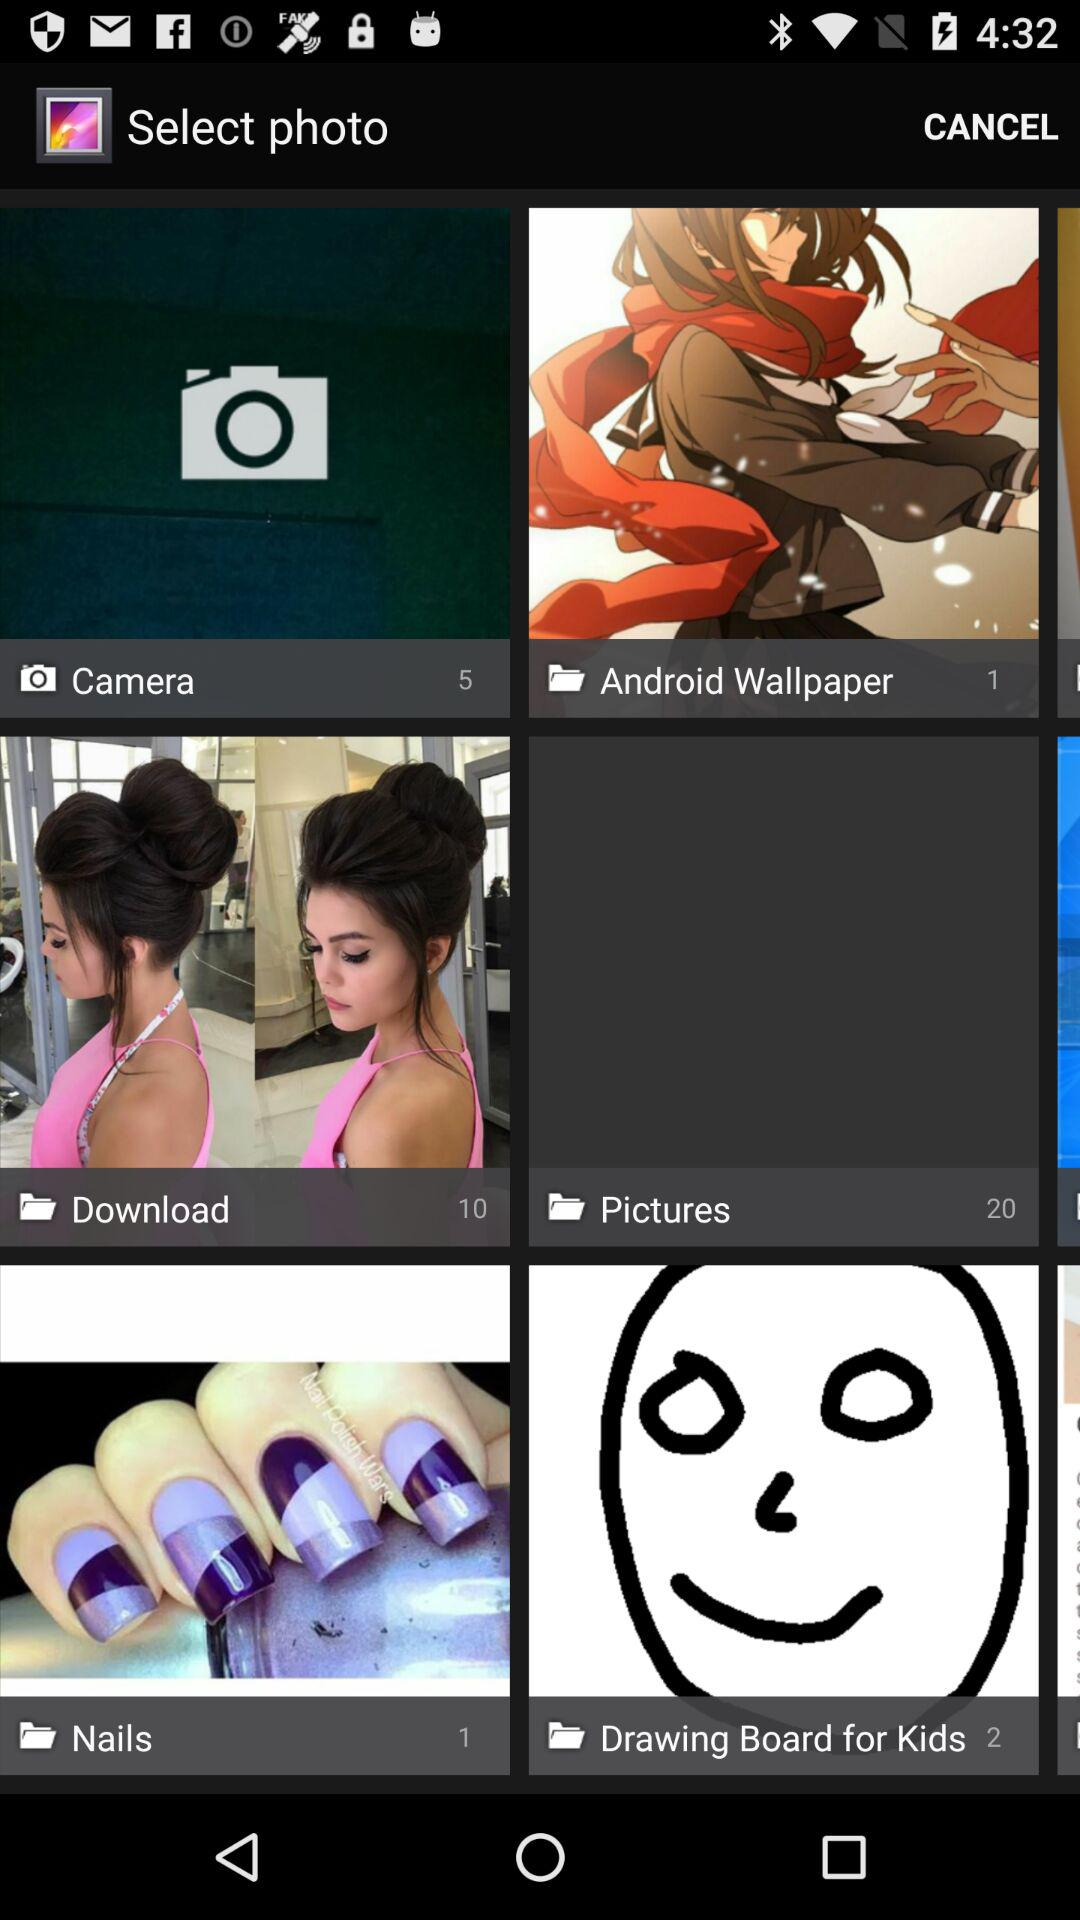How many photos are in "Download"? There are 10 photos. 